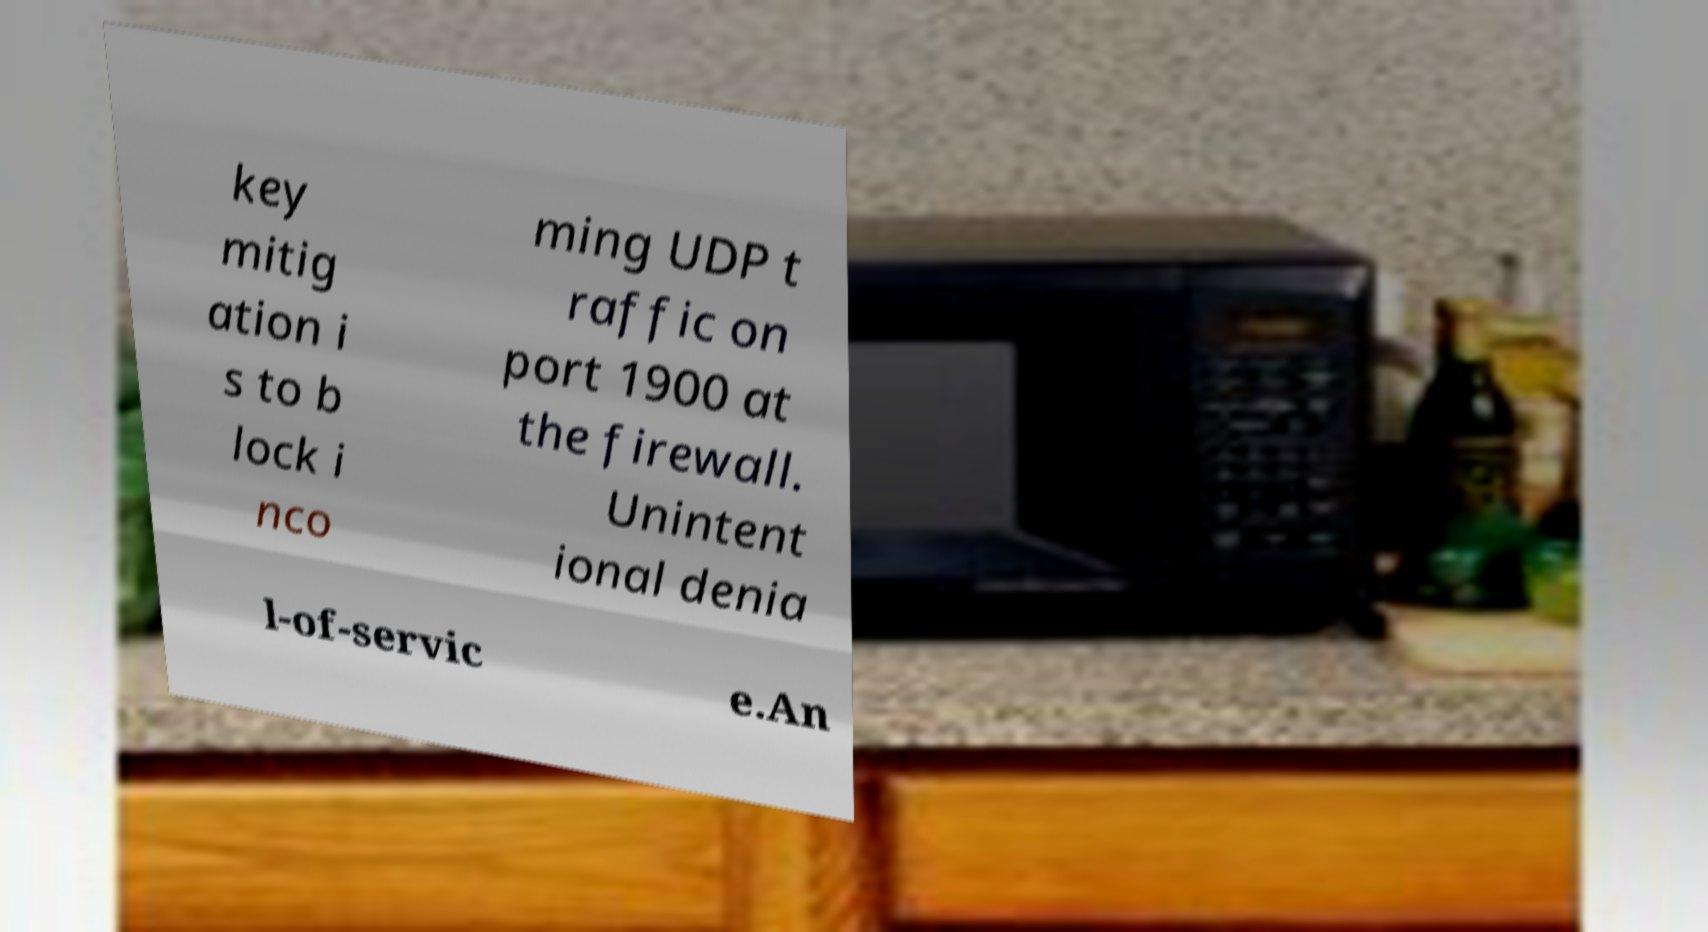I need the written content from this picture converted into text. Can you do that? key mitig ation i s to b lock i nco ming UDP t raffic on port 1900 at the firewall. Unintent ional denia l-of-servic e.An 